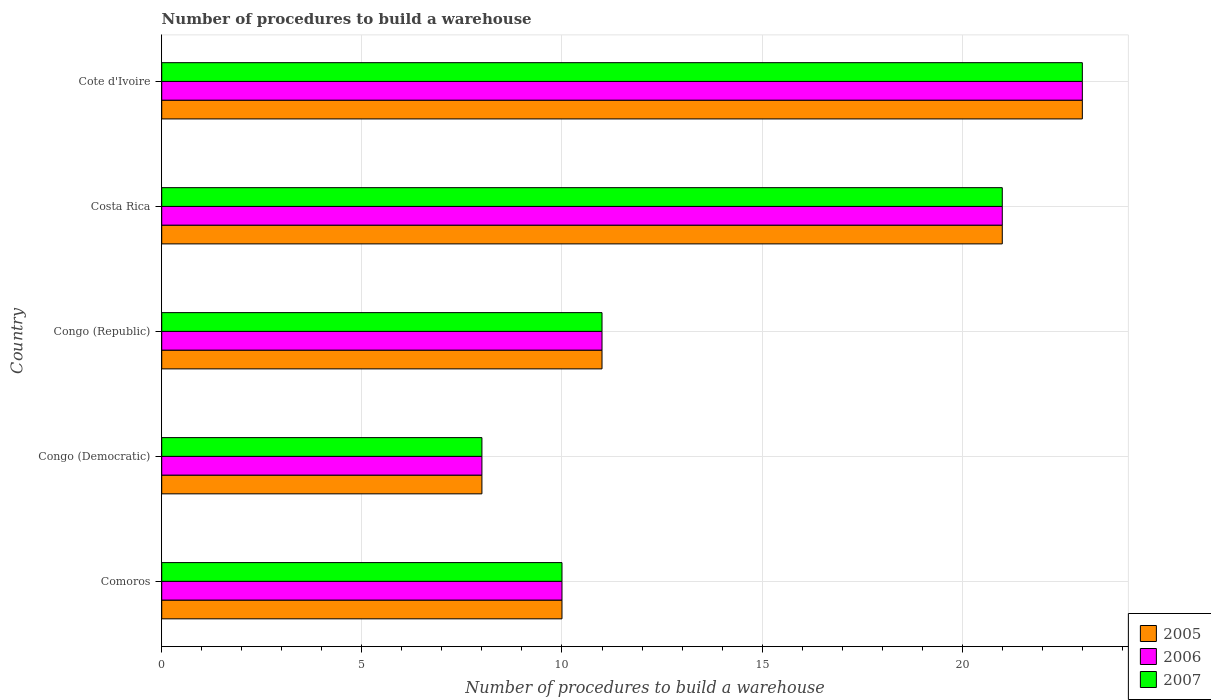How many groups of bars are there?
Keep it short and to the point. 5. Are the number of bars per tick equal to the number of legend labels?
Ensure brevity in your answer.  Yes. Are the number of bars on each tick of the Y-axis equal?
Provide a short and direct response. Yes. How many bars are there on the 2nd tick from the top?
Make the answer very short. 3. How many bars are there on the 5th tick from the bottom?
Your answer should be very brief. 3. What is the label of the 3rd group of bars from the top?
Make the answer very short. Congo (Republic). In how many cases, is the number of bars for a given country not equal to the number of legend labels?
Ensure brevity in your answer.  0. Across all countries, what is the minimum number of procedures to build a warehouse in in 2006?
Your answer should be compact. 8. In which country was the number of procedures to build a warehouse in in 2007 maximum?
Make the answer very short. Cote d'Ivoire. In which country was the number of procedures to build a warehouse in in 2007 minimum?
Provide a short and direct response. Congo (Democratic). What is the difference between the number of procedures to build a warehouse in in 2005 in Costa Rica and that in Cote d'Ivoire?
Provide a succinct answer. -2. What is the difference between the number of procedures to build a warehouse in in 2006 in Comoros and the number of procedures to build a warehouse in in 2005 in Congo (Republic)?
Provide a succinct answer. -1. What is the difference between the number of procedures to build a warehouse in in 2007 and number of procedures to build a warehouse in in 2005 in Cote d'Ivoire?
Give a very brief answer. 0. In how many countries, is the number of procedures to build a warehouse in in 2006 greater than 6 ?
Offer a terse response. 5. What is the ratio of the number of procedures to build a warehouse in in 2005 in Comoros to that in Cote d'Ivoire?
Offer a very short reply. 0.43. Is the number of procedures to build a warehouse in in 2005 in Comoros less than that in Costa Rica?
Your response must be concise. Yes. Is the difference between the number of procedures to build a warehouse in in 2007 in Comoros and Congo (Democratic) greater than the difference between the number of procedures to build a warehouse in in 2005 in Comoros and Congo (Democratic)?
Provide a short and direct response. No. What is the difference between the highest and the second highest number of procedures to build a warehouse in in 2007?
Keep it short and to the point. 2. In how many countries, is the number of procedures to build a warehouse in in 2006 greater than the average number of procedures to build a warehouse in in 2006 taken over all countries?
Your answer should be very brief. 2. What does the 3rd bar from the top in Costa Rica represents?
Provide a short and direct response. 2005. Is it the case that in every country, the sum of the number of procedures to build a warehouse in in 2006 and number of procedures to build a warehouse in in 2007 is greater than the number of procedures to build a warehouse in in 2005?
Offer a terse response. Yes. How many countries are there in the graph?
Offer a very short reply. 5. Where does the legend appear in the graph?
Keep it short and to the point. Bottom right. How are the legend labels stacked?
Provide a short and direct response. Vertical. What is the title of the graph?
Give a very brief answer. Number of procedures to build a warehouse. What is the label or title of the X-axis?
Your response must be concise. Number of procedures to build a warehouse. What is the Number of procedures to build a warehouse of 2006 in Comoros?
Offer a very short reply. 10. What is the Number of procedures to build a warehouse in 2007 in Comoros?
Make the answer very short. 10. What is the Number of procedures to build a warehouse of 2007 in Congo (Democratic)?
Give a very brief answer. 8. What is the Number of procedures to build a warehouse in 2005 in Congo (Republic)?
Offer a terse response. 11. What is the Number of procedures to build a warehouse in 2005 in Costa Rica?
Ensure brevity in your answer.  21. What is the Number of procedures to build a warehouse in 2006 in Costa Rica?
Your answer should be compact. 21. What is the Number of procedures to build a warehouse of 2007 in Costa Rica?
Make the answer very short. 21. What is the Number of procedures to build a warehouse in 2005 in Cote d'Ivoire?
Your answer should be very brief. 23. Across all countries, what is the maximum Number of procedures to build a warehouse of 2006?
Your response must be concise. 23. Across all countries, what is the maximum Number of procedures to build a warehouse of 2007?
Provide a short and direct response. 23. Across all countries, what is the minimum Number of procedures to build a warehouse of 2007?
Make the answer very short. 8. What is the total Number of procedures to build a warehouse in 2005 in the graph?
Keep it short and to the point. 73. What is the total Number of procedures to build a warehouse in 2006 in the graph?
Your response must be concise. 73. What is the difference between the Number of procedures to build a warehouse in 2007 in Comoros and that in Congo (Democratic)?
Provide a succinct answer. 2. What is the difference between the Number of procedures to build a warehouse in 2007 in Comoros and that in Costa Rica?
Provide a succinct answer. -11. What is the difference between the Number of procedures to build a warehouse of 2005 in Comoros and that in Cote d'Ivoire?
Ensure brevity in your answer.  -13. What is the difference between the Number of procedures to build a warehouse of 2006 in Comoros and that in Cote d'Ivoire?
Keep it short and to the point. -13. What is the difference between the Number of procedures to build a warehouse of 2005 in Congo (Democratic) and that in Congo (Republic)?
Your answer should be compact. -3. What is the difference between the Number of procedures to build a warehouse in 2007 in Congo (Democratic) and that in Congo (Republic)?
Offer a very short reply. -3. What is the difference between the Number of procedures to build a warehouse in 2006 in Congo (Democratic) and that in Costa Rica?
Provide a succinct answer. -13. What is the difference between the Number of procedures to build a warehouse of 2007 in Congo (Democratic) and that in Cote d'Ivoire?
Provide a succinct answer. -15. What is the difference between the Number of procedures to build a warehouse in 2005 in Congo (Republic) and that in Costa Rica?
Keep it short and to the point. -10. What is the difference between the Number of procedures to build a warehouse of 2006 in Congo (Republic) and that in Cote d'Ivoire?
Offer a terse response. -12. What is the difference between the Number of procedures to build a warehouse in 2007 in Congo (Republic) and that in Cote d'Ivoire?
Give a very brief answer. -12. What is the difference between the Number of procedures to build a warehouse in 2006 in Costa Rica and that in Cote d'Ivoire?
Make the answer very short. -2. What is the difference between the Number of procedures to build a warehouse in 2007 in Costa Rica and that in Cote d'Ivoire?
Offer a terse response. -2. What is the difference between the Number of procedures to build a warehouse in 2006 in Comoros and the Number of procedures to build a warehouse in 2007 in Congo (Democratic)?
Offer a very short reply. 2. What is the difference between the Number of procedures to build a warehouse in 2006 in Comoros and the Number of procedures to build a warehouse in 2007 in Congo (Republic)?
Provide a succinct answer. -1. What is the difference between the Number of procedures to build a warehouse of 2005 in Comoros and the Number of procedures to build a warehouse of 2006 in Costa Rica?
Your answer should be compact. -11. What is the difference between the Number of procedures to build a warehouse of 2005 in Comoros and the Number of procedures to build a warehouse of 2007 in Costa Rica?
Ensure brevity in your answer.  -11. What is the difference between the Number of procedures to build a warehouse in 2006 in Comoros and the Number of procedures to build a warehouse in 2007 in Costa Rica?
Your answer should be very brief. -11. What is the difference between the Number of procedures to build a warehouse of 2005 in Comoros and the Number of procedures to build a warehouse of 2006 in Cote d'Ivoire?
Offer a very short reply. -13. What is the difference between the Number of procedures to build a warehouse of 2005 in Comoros and the Number of procedures to build a warehouse of 2007 in Cote d'Ivoire?
Your response must be concise. -13. What is the difference between the Number of procedures to build a warehouse in 2006 in Comoros and the Number of procedures to build a warehouse in 2007 in Cote d'Ivoire?
Offer a very short reply. -13. What is the difference between the Number of procedures to build a warehouse of 2005 in Congo (Democratic) and the Number of procedures to build a warehouse of 2006 in Congo (Republic)?
Keep it short and to the point. -3. What is the difference between the Number of procedures to build a warehouse in 2005 in Congo (Democratic) and the Number of procedures to build a warehouse in 2007 in Congo (Republic)?
Provide a short and direct response. -3. What is the difference between the Number of procedures to build a warehouse of 2005 in Congo (Democratic) and the Number of procedures to build a warehouse of 2007 in Costa Rica?
Provide a succinct answer. -13. What is the difference between the Number of procedures to build a warehouse in 2006 in Congo (Democratic) and the Number of procedures to build a warehouse in 2007 in Costa Rica?
Keep it short and to the point. -13. What is the difference between the Number of procedures to build a warehouse in 2005 in Congo (Democratic) and the Number of procedures to build a warehouse in 2006 in Cote d'Ivoire?
Provide a short and direct response. -15. What is the difference between the Number of procedures to build a warehouse of 2005 in Congo (Republic) and the Number of procedures to build a warehouse of 2006 in Costa Rica?
Your answer should be very brief. -10. What is the difference between the Number of procedures to build a warehouse in 2005 in Congo (Republic) and the Number of procedures to build a warehouse in 2007 in Costa Rica?
Keep it short and to the point. -10. What is the difference between the Number of procedures to build a warehouse in 2005 in Congo (Republic) and the Number of procedures to build a warehouse in 2007 in Cote d'Ivoire?
Make the answer very short. -12. What is the difference between the Number of procedures to build a warehouse of 2006 in Congo (Republic) and the Number of procedures to build a warehouse of 2007 in Cote d'Ivoire?
Your answer should be very brief. -12. What is the difference between the Number of procedures to build a warehouse in 2005 in Costa Rica and the Number of procedures to build a warehouse in 2006 in Cote d'Ivoire?
Offer a very short reply. -2. What is the difference between the Number of procedures to build a warehouse in 2006 in Costa Rica and the Number of procedures to build a warehouse in 2007 in Cote d'Ivoire?
Offer a terse response. -2. What is the average Number of procedures to build a warehouse in 2005 per country?
Ensure brevity in your answer.  14.6. What is the average Number of procedures to build a warehouse in 2006 per country?
Provide a succinct answer. 14.6. What is the difference between the Number of procedures to build a warehouse in 2005 and Number of procedures to build a warehouse in 2006 in Congo (Democratic)?
Your answer should be very brief. 0. What is the difference between the Number of procedures to build a warehouse in 2005 and Number of procedures to build a warehouse in 2007 in Congo (Democratic)?
Make the answer very short. 0. What is the difference between the Number of procedures to build a warehouse of 2006 and Number of procedures to build a warehouse of 2007 in Congo (Democratic)?
Provide a short and direct response. 0. What is the difference between the Number of procedures to build a warehouse of 2005 and Number of procedures to build a warehouse of 2006 in Congo (Republic)?
Your answer should be very brief. 0. What is the difference between the Number of procedures to build a warehouse in 2005 and Number of procedures to build a warehouse in 2007 in Congo (Republic)?
Your answer should be compact. 0. What is the difference between the Number of procedures to build a warehouse in 2006 and Number of procedures to build a warehouse in 2007 in Congo (Republic)?
Ensure brevity in your answer.  0. What is the difference between the Number of procedures to build a warehouse of 2005 and Number of procedures to build a warehouse of 2006 in Costa Rica?
Keep it short and to the point. 0. What is the difference between the Number of procedures to build a warehouse of 2005 and Number of procedures to build a warehouse of 2006 in Cote d'Ivoire?
Your answer should be compact. 0. What is the difference between the Number of procedures to build a warehouse of 2005 and Number of procedures to build a warehouse of 2007 in Cote d'Ivoire?
Make the answer very short. 0. What is the ratio of the Number of procedures to build a warehouse in 2005 in Comoros to that in Congo (Democratic)?
Provide a short and direct response. 1.25. What is the ratio of the Number of procedures to build a warehouse in 2007 in Comoros to that in Congo (Democratic)?
Ensure brevity in your answer.  1.25. What is the ratio of the Number of procedures to build a warehouse in 2006 in Comoros to that in Congo (Republic)?
Your answer should be very brief. 0.91. What is the ratio of the Number of procedures to build a warehouse in 2007 in Comoros to that in Congo (Republic)?
Make the answer very short. 0.91. What is the ratio of the Number of procedures to build a warehouse in 2005 in Comoros to that in Costa Rica?
Your answer should be compact. 0.48. What is the ratio of the Number of procedures to build a warehouse in 2006 in Comoros to that in Costa Rica?
Make the answer very short. 0.48. What is the ratio of the Number of procedures to build a warehouse of 2007 in Comoros to that in Costa Rica?
Your answer should be very brief. 0.48. What is the ratio of the Number of procedures to build a warehouse in 2005 in Comoros to that in Cote d'Ivoire?
Give a very brief answer. 0.43. What is the ratio of the Number of procedures to build a warehouse of 2006 in Comoros to that in Cote d'Ivoire?
Provide a short and direct response. 0.43. What is the ratio of the Number of procedures to build a warehouse of 2007 in Comoros to that in Cote d'Ivoire?
Provide a short and direct response. 0.43. What is the ratio of the Number of procedures to build a warehouse of 2005 in Congo (Democratic) to that in Congo (Republic)?
Your answer should be compact. 0.73. What is the ratio of the Number of procedures to build a warehouse in 2006 in Congo (Democratic) to that in Congo (Republic)?
Keep it short and to the point. 0.73. What is the ratio of the Number of procedures to build a warehouse of 2007 in Congo (Democratic) to that in Congo (Republic)?
Keep it short and to the point. 0.73. What is the ratio of the Number of procedures to build a warehouse in 2005 in Congo (Democratic) to that in Costa Rica?
Provide a short and direct response. 0.38. What is the ratio of the Number of procedures to build a warehouse of 2006 in Congo (Democratic) to that in Costa Rica?
Offer a very short reply. 0.38. What is the ratio of the Number of procedures to build a warehouse in 2007 in Congo (Democratic) to that in Costa Rica?
Ensure brevity in your answer.  0.38. What is the ratio of the Number of procedures to build a warehouse of 2005 in Congo (Democratic) to that in Cote d'Ivoire?
Provide a succinct answer. 0.35. What is the ratio of the Number of procedures to build a warehouse in 2006 in Congo (Democratic) to that in Cote d'Ivoire?
Offer a terse response. 0.35. What is the ratio of the Number of procedures to build a warehouse of 2007 in Congo (Democratic) to that in Cote d'Ivoire?
Offer a very short reply. 0.35. What is the ratio of the Number of procedures to build a warehouse of 2005 in Congo (Republic) to that in Costa Rica?
Keep it short and to the point. 0.52. What is the ratio of the Number of procedures to build a warehouse of 2006 in Congo (Republic) to that in Costa Rica?
Provide a succinct answer. 0.52. What is the ratio of the Number of procedures to build a warehouse in 2007 in Congo (Republic) to that in Costa Rica?
Make the answer very short. 0.52. What is the ratio of the Number of procedures to build a warehouse of 2005 in Congo (Republic) to that in Cote d'Ivoire?
Keep it short and to the point. 0.48. What is the ratio of the Number of procedures to build a warehouse of 2006 in Congo (Republic) to that in Cote d'Ivoire?
Provide a short and direct response. 0.48. What is the ratio of the Number of procedures to build a warehouse of 2007 in Congo (Republic) to that in Cote d'Ivoire?
Provide a short and direct response. 0.48. What is the ratio of the Number of procedures to build a warehouse in 2005 in Costa Rica to that in Cote d'Ivoire?
Your answer should be compact. 0.91. What is the ratio of the Number of procedures to build a warehouse in 2006 in Costa Rica to that in Cote d'Ivoire?
Give a very brief answer. 0.91. What is the difference between the highest and the second highest Number of procedures to build a warehouse of 2005?
Give a very brief answer. 2. What is the difference between the highest and the second highest Number of procedures to build a warehouse of 2006?
Offer a very short reply. 2. What is the difference between the highest and the lowest Number of procedures to build a warehouse of 2006?
Provide a short and direct response. 15. What is the difference between the highest and the lowest Number of procedures to build a warehouse in 2007?
Keep it short and to the point. 15. 